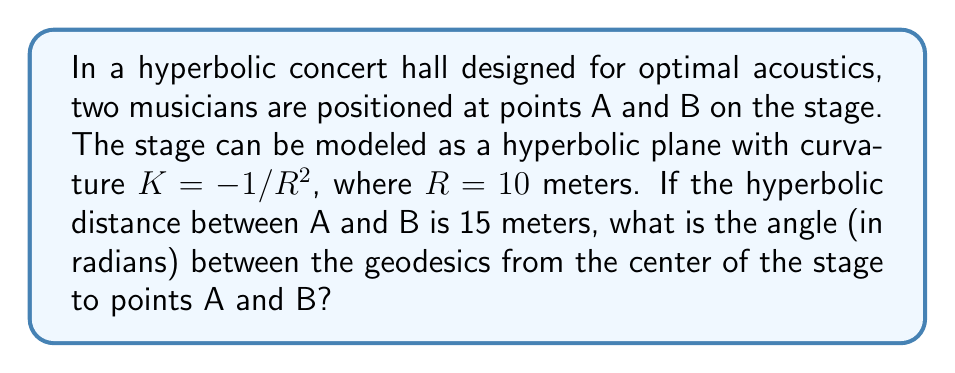Provide a solution to this math problem. Let's approach this step-by-step:

1) In hyperbolic geometry, we use the hyperbolic law of cosines to relate distances and angles. For a triangle with sides a, b, c and angles A, B, C opposite to these sides respectively, the law states:

   $$\cosh(a/R) = \cosh(b/R)\cosh(c/R) - \sinh(b/R)\sinh(c/R)\cos(A)$$

2) In our case, we're looking at an isosceles triangle where:
   - The equal sides are the geodesics from the center to A and B. Let's call this distance x.
   - The base of the triangle is the geodesic between A and B, which we're told is 15 meters.
   - The angle we're looking for is at the center, let's call it θ.

3) Applying the hyperbolic law of cosines:

   $$\cosh(15/10) = \cosh(x/10)\cosh(x/10) - \sinh(x/10)\sinh(x/10)\cos(θ)$$

4) Simplify:

   $$\cosh(1.5) = \cosh^2(x/10) - \sinh^2(x/10)\cos(θ)$$

5) We know that $\cosh^2(t) - \sinh^2(t) = 1$ for any t. So:

   $$\cosh(1.5) = 1 + \sinh^2(x/10)(1 - \cos(θ))$$

6) Solve for $\cos(θ)$:

   $$\cos(θ) = 1 - \frac{\cosh(1.5) - 1}{\sinh^2(x/10)}$$

7) Calculate:
   $\cosh(1.5) ≈ 2.352409$
   
   Therefore:

   $$\cos(θ) = 1 - \frac{1.352409}{\sinh^2(x/10)}$$

8) The exact value of x is not given, but we can deduce that it must be less than 15 (as the hyperbolic distance between two points is always greater than the Euclidean distance). The cosine of the angle will be positive and close to 1, indicating a relatively small angle.

9) To get the final answer, we would take the arccos of this expression:

   $$θ = \arccos\left(1 - \frac{1.352409}{\sinh^2(x/10)}\right)$$
Answer: $θ = \arccos\left(1 - \frac{1.352409}{\sinh^2(x/10)}\right)$ radians 